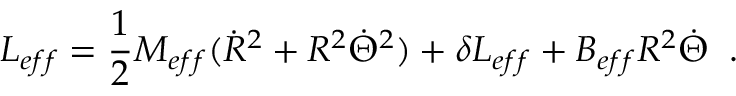Convert formula to latex. <formula><loc_0><loc_0><loc_500><loc_500>L _ { e f f } = \frac { 1 } { 2 } M _ { e f f } ( \dot { R } ^ { 2 } + R ^ { 2 } \dot { \Theta } ^ { 2 } ) + \delta L _ { e f f } + B _ { e f f } R ^ { 2 } \dot { \Theta } \, .</formula> 